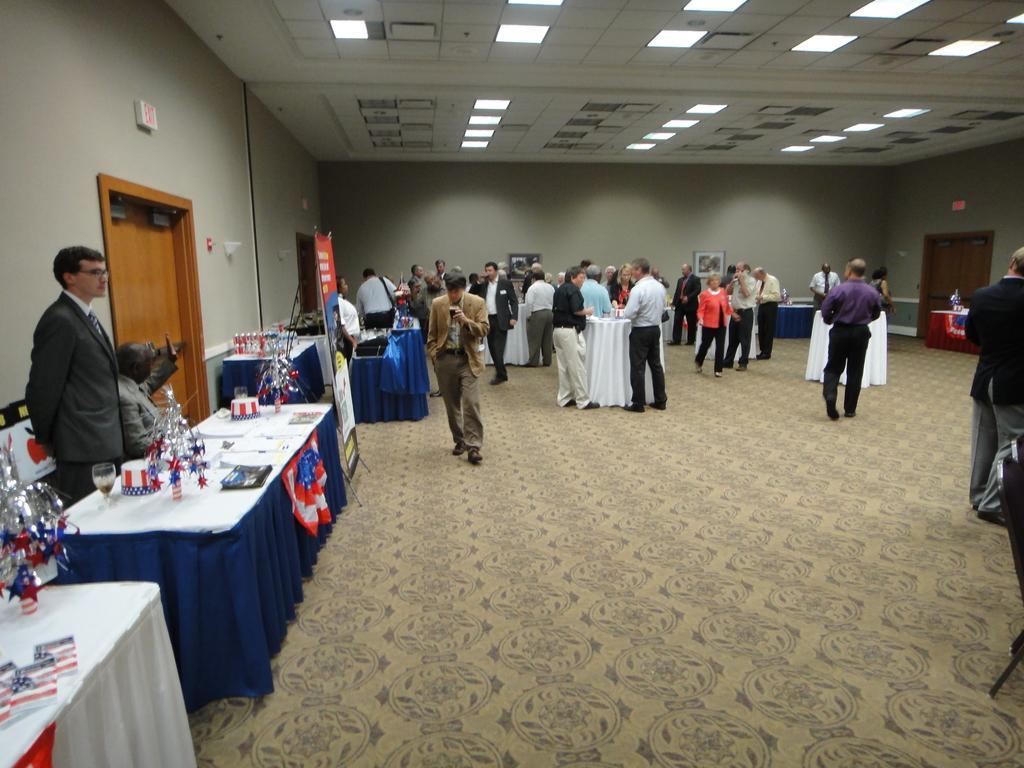In one or two sentences, can you explain what this image depicts? In this picture, we can see a few people, we can see the floor with some objects, and we can see some tables covered with cloth, and we can see some objects on the tables like bottles, glass, we can see the wall with doors, and some objects attached to it, we can see the roof with lights. 